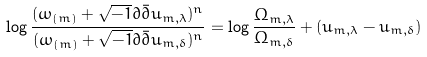Convert formula to latex. <formula><loc_0><loc_0><loc_500><loc_500>\log \frac { ( \omega _ { ( m ) } + \sqrt { - 1 } \partial \bar { \partial } u _ { m , \lambda } ) ^ { n } } { ( \omega _ { ( m ) } + \sqrt { - 1 } \partial \bar { \partial } u _ { m , \delta } ) ^ { n } } = \log \frac { \Omega _ { m , \lambda } } { \Omega _ { m , \delta } } + ( u _ { m , \lambda } - u _ { m , \delta } )</formula> 